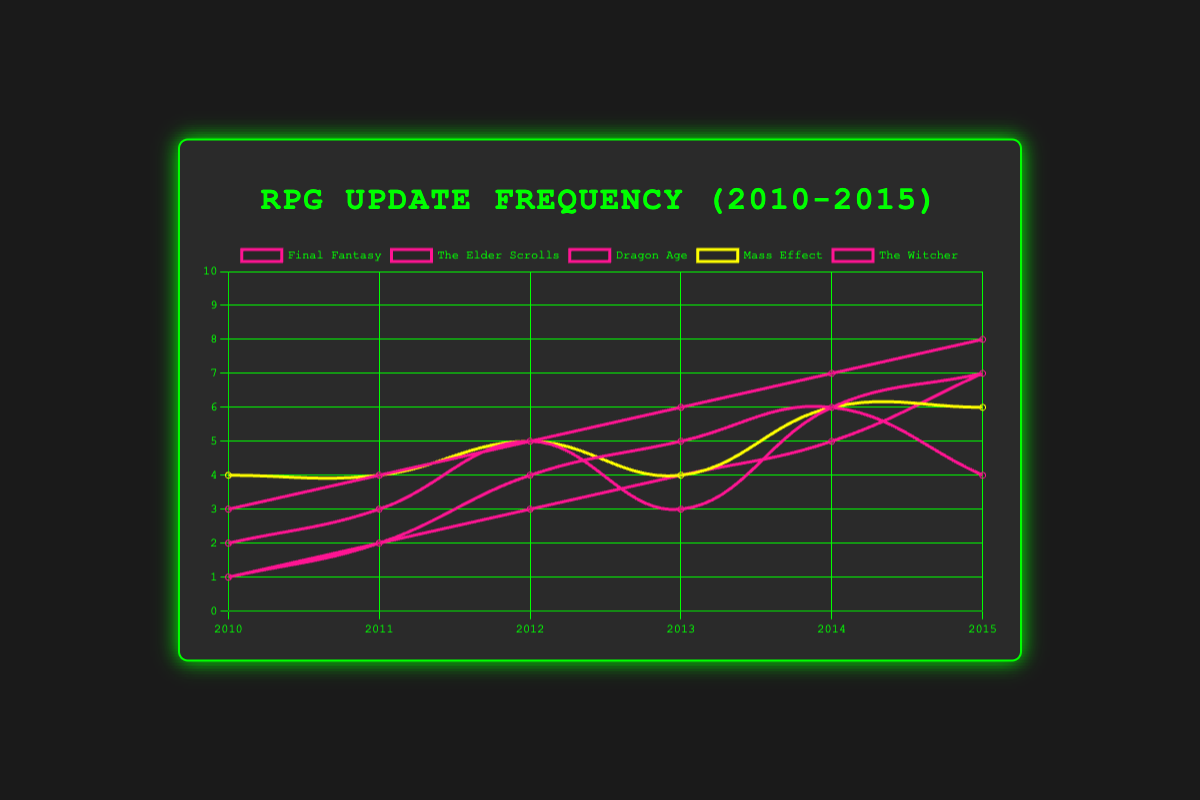Which game series had the highest number of updates in 2015? To find the answer, look at the data points for the year 2015 across all game series and find the highest value. Final Fantasy had 8 updates, The Elder Scrolls had 4, Dragon Age had 7, Mass Effect had 6, and The Witcher had 7. Thus, Final Fantasy had the highest number.
Answer: Final Fantasy In which year did Dragon Age see a significant increase in updates and by how much did it increase? To determine the year of significant increase, examine Dragon Age updates year by year. The biggest jump occurred from 2011 to 2012, increasing from 3 updates to 5 updates, an increase of 2.
Answer: 2012, 2 Compare the number of updates for The Witcher and Mass Effect in 2013. Which game had more updates? Look at the 2013 data points for both The Witcher and Mass Effect. The Witcher had 4 updates and Mass Effect had 4 updates as well. Thus, they had the same number of updates.
Answer: Same Which game series showed a steady increase in updates from 2010 to 2015? To determine this, plot the data points for each game series and observe if there's a consistent upward trend. Final Fantasy shows a steady increase: starting at 3 and rising to 8 from 2010 to 2015.
Answer: Final Fantasy What is the total number of updates for The Elder Scrolls over the years 2010 to 2015? Sum the number of updates for each year for The Elder Scrolls. The updates are 1, 2, 4, 5, 6, and 4 respectively. Therefore, 1 + 2 + 4 + 5 + 6 + 4 = 22.
Answer: 22 By how much did the number of updates for Final Fantasy increase from its lowest point in 2010 to its highest point in 2015? Final Fantasy's updates in 2010 were 3, and in 2015 they were 8. The increase is 8 - 3 = 5.
Answer: 5 Which game series had the fewest updates in 2010? Look at the data points for the year 2010 across all game series. The Elder Scrolls and The Witcher each had 1 update, which is the fewest.
Answer: The Elder Scrolls and The Witcher Did any game series have the same number of updates every year? To verify, analyze the data for consistency across the years. Mass Effect had the most consistent updates: 4, 4, 5, 4, 6, 6, but not the same every year. Thus, no series had the same number every year.
Answer: No What is the average number of updates per year for Mass Effect from 2010 to 2015? To find the average, sum the updates for all years for Mass Effect and divide by the number of years. The updates are 4, 4, 5, 4, 6, 6. Sum = 4 + 4 + 5 + 4 + 6 + 6 = 29. The number of years is 6. Average = 29/6 = 4.83.
Answer: 4.83 